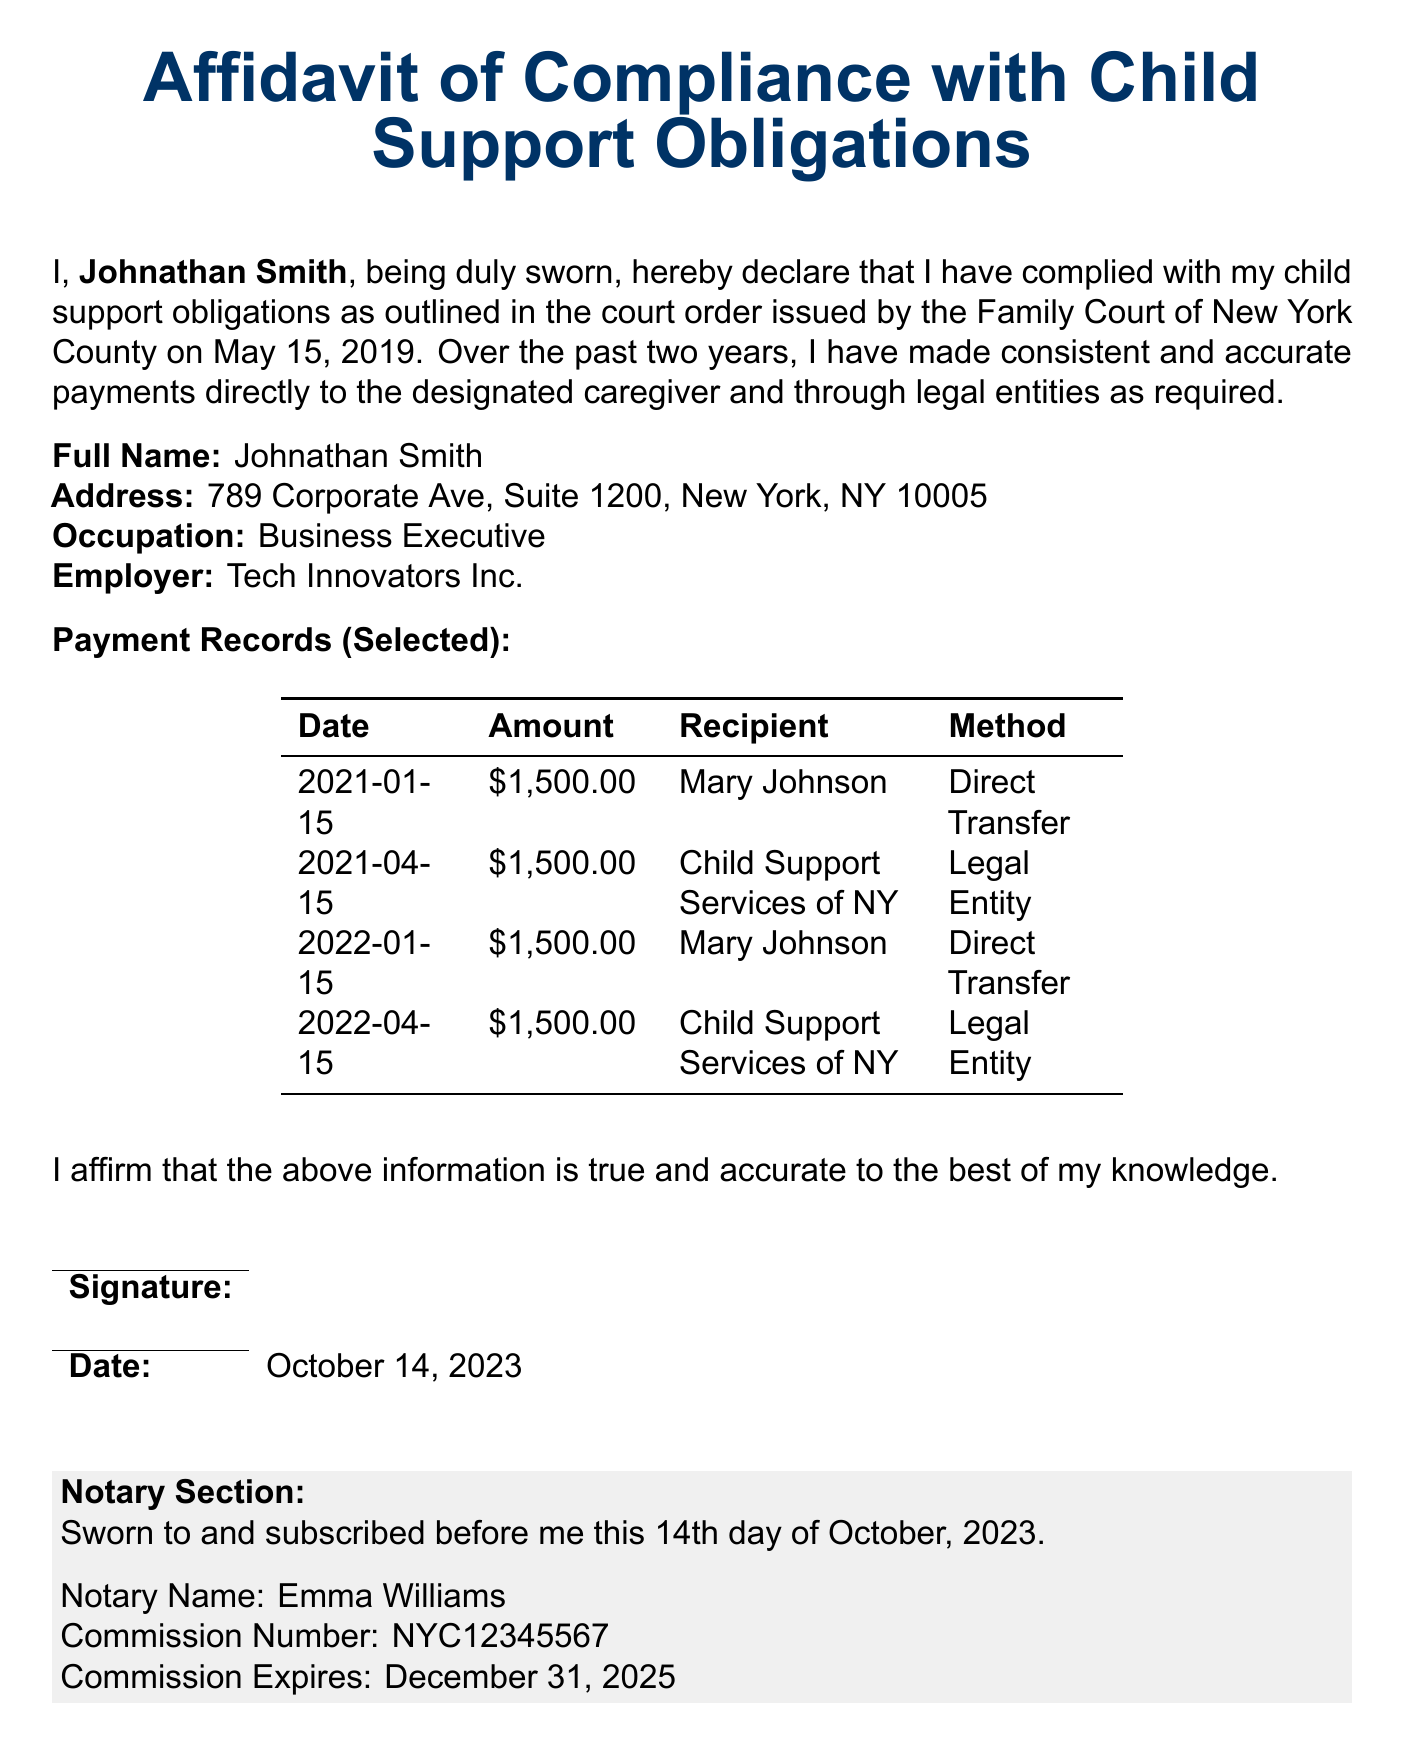What is the full name of the affiant? The affiant's full name is mentioned at the beginning of the document as the person making the affidavit.
Answer: Johnathan Smith What is Johnathan Smith's occupation? The affiant's occupation is stated in the document under personal information.
Answer: Business Executive What is the address listed in the affidavit? The address is provided in the personal information section of the document.
Answer: 789 Corporate Ave, Suite 1200, New York, NY 10005 How much was paid on January 15, 2021? The payment amount for this specific date is listed in the payment records table.
Answer: $1,500.00 How many payments were made directly to Mary Johnson? The number of payments can be calculated based on the recipient entries in the payment records section.
Answer: 2 What organization did Johnathan Smith use on April 15, 2021, for payment? The legal entity used for this payment can be found in the payment records table under the specific date.
Answer: Child Support Services of NY What is the date of the notary's signature? The date when the notary signed the document is mentioned in the notary section.
Answer: October 14, 2023 When does the notary's commission expire? This information can be found in the notary section at the end of the document.
Answer: December 31, 2025 What is the commission number of the notary? The notary's commission number is listed in the notary section.
Answer: NYC12345567 